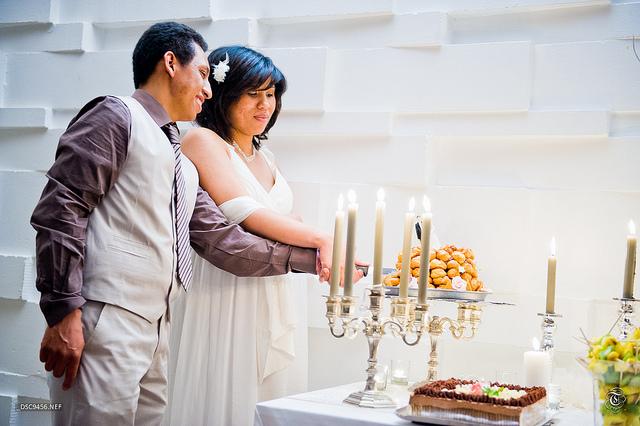Are the man and woman single?
Give a very brief answer. No. What milestone is the couple celebrating?
Answer briefly. Wedding. What color is the flower in her hair?
Be succinct. White. 